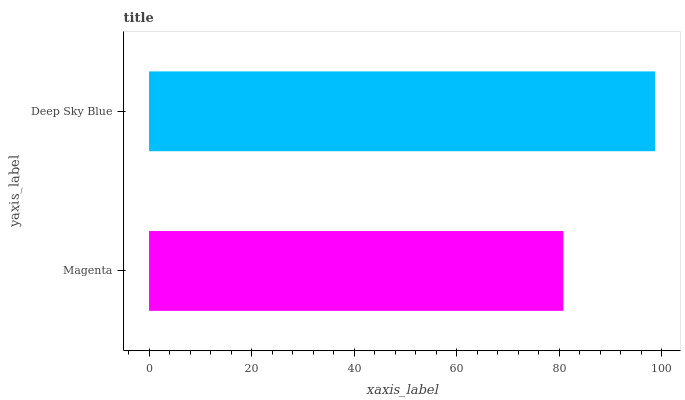Is Magenta the minimum?
Answer yes or no. Yes. Is Deep Sky Blue the maximum?
Answer yes or no. Yes. Is Deep Sky Blue the minimum?
Answer yes or no. No. Is Deep Sky Blue greater than Magenta?
Answer yes or no. Yes. Is Magenta less than Deep Sky Blue?
Answer yes or no. Yes. Is Magenta greater than Deep Sky Blue?
Answer yes or no. No. Is Deep Sky Blue less than Magenta?
Answer yes or no. No. Is Deep Sky Blue the high median?
Answer yes or no. Yes. Is Magenta the low median?
Answer yes or no. Yes. Is Magenta the high median?
Answer yes or no. No. Is Deep Sky Blue the low median?
Answer yes or no. No. 